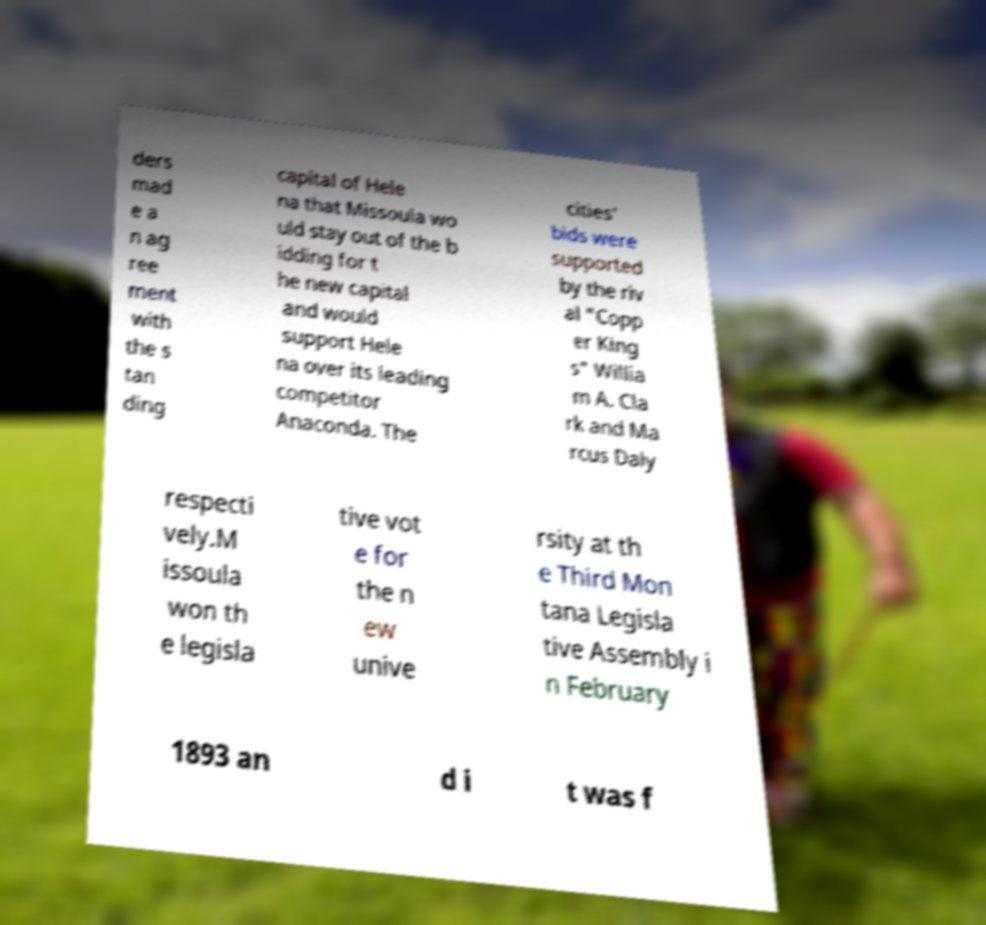There's text embedded in this image that I need extracted. Can you transcribe it verbatim? ders mad e a n ag ree ment with the s tan ding capital of Hele na that Missoula wo uld stay out of the b idding for t he new capital and would support Hele na over its leading competitor Anaconda. The cities' bids were supported by the riv al "Copp er King s" Willia m A. Cla rk and Ma rcus Daly respecti vely.M issoula won th e legisla tive vot e for the n ew unive rsity at th e Third Mon tana Legisla tive Assembly i n February 1893 an d i t was f 